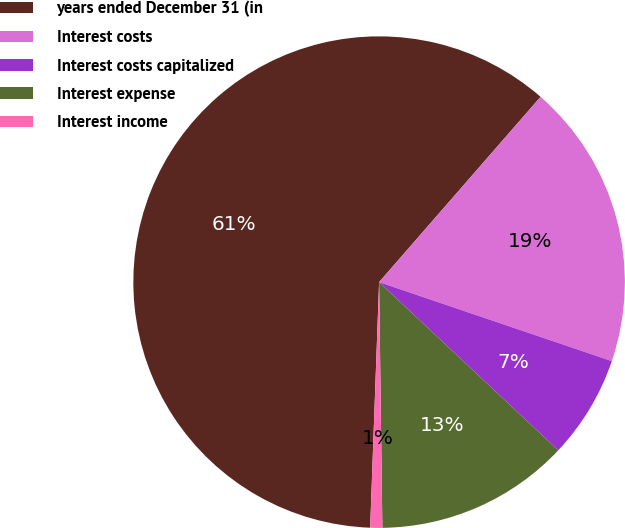Convert chart to OTSL. <chart><loc_0><loc_0><loc_500><loc_500><pie_chart><fcel>years ended December 31 (in<fcel>Interest costs<fcel>Interest costs capitalized<fcel>Interest expense<fcel>Interest income<nl><fcel>60.83%<fcel>18.8%<fcel>6.79%<fcel>12.79%<fcel>0.79%<nl></chart> 